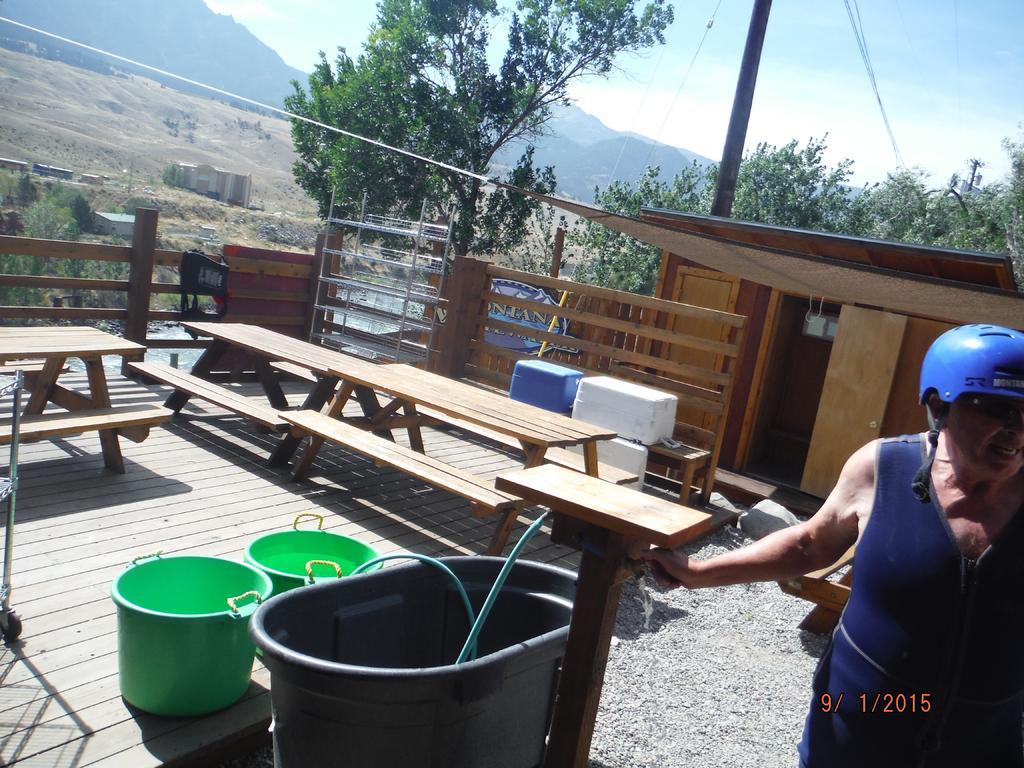Describe this image in one or two sentences. A woman is standing wearing a blue color helmet. There is stool like wooden thing behind her. A pipe is running through a tub and other two containers beside it. There are three benches beside. There are some racks and containers behind her. There are some trees,barren land and hill in the background. 